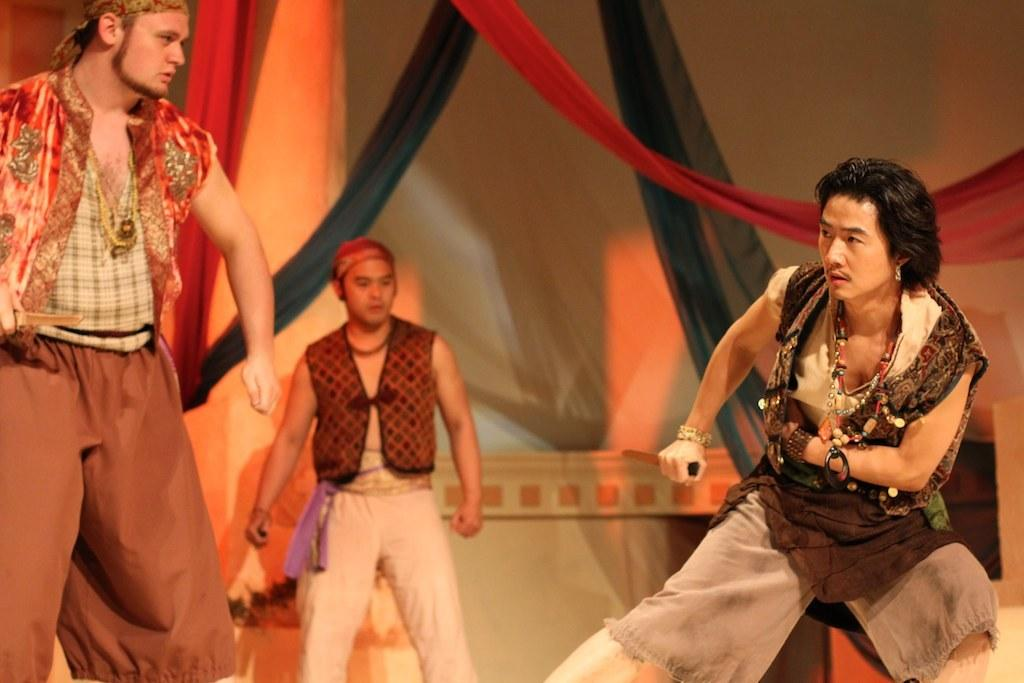How many people are in the image? There are three persons in the image. What are the persons in the image doing? The persons appear to be acting in a play. What can be seen in the background of the image? There are curtains and clothes in the background of the image. Where is the mom sitting in the image? There is no mom present in the image; it features three persons acting in a play. What type of office furniture can be seen in the image? There is no office furniture present in the image. 